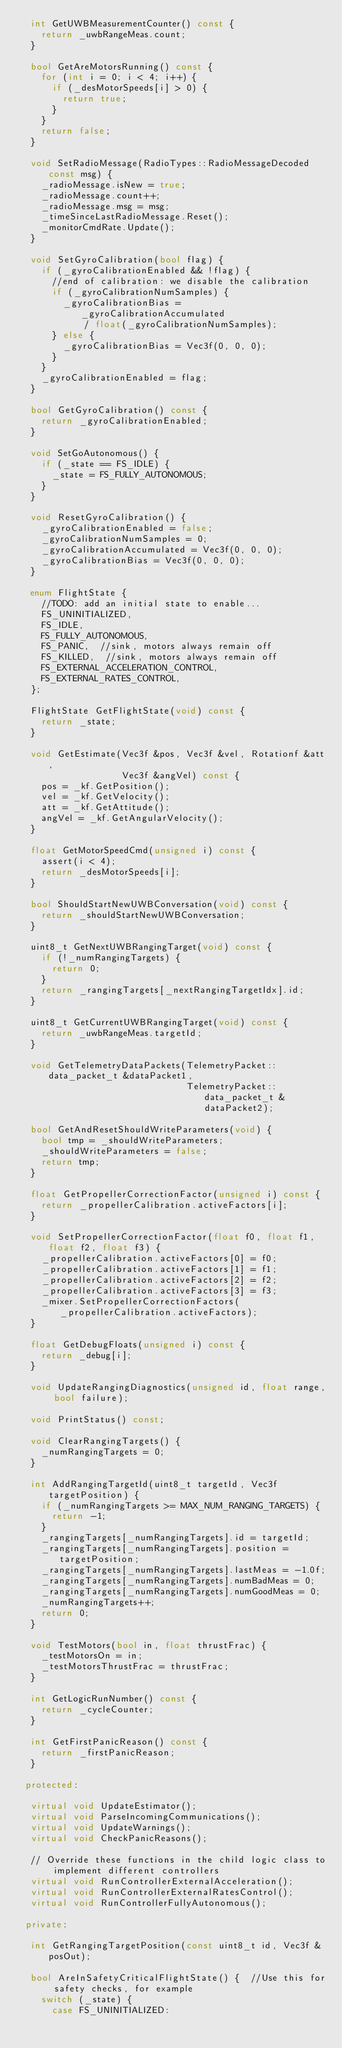<code> <loc_0><loc_0><loc_500><loc_500><_C++_>  int GetUWBMeasurementCounter() const {
    return _uwbRangeMeas.count;
  }

  bool GetAreMotorsRunning() const {
    for (int i = 0; i < 4; i++) {
      if (_desMotorSpeeds[i] > 0) {
        return true;
      }
    }
    return false;
  }

  void SetRadioMessage(RadioTypes::RadioMessageDecoded const msg) {
    _radioMessage.isNew = true;
    _radioMessage.count++;
    _radioMessage.msg = msg;
    _timeSinceLastRadioMessage.Reset();
    _monitorCmdRate.Update();
  }

  void SetGyroCalibration(bool flag) {
    if (_gyroCalibrationEnabled && !flag) {
      //end of calibration: we disable the calibration
      if (_gyroCalibrationNumSamples) {
        _gyroCalibrationBias = _gyroCalibrationAccumulated
            / float(_gyroCalibrationNumSamples);
      } else {
        _gyroCalibrationBias = Vec3f(0, 0, 0);
      }
    }
    _gyroCalibrationEnabled = flag;
  }

  bool GetGyroCalibration() const {
    return _gyroCalibrationEnabled;
  }

  void SetGoAutonomous() {
    if (_state == FS_IDLE) {
      _state = FS_FULLY_AUTONOMOUS;
    }
  }

  void ResetGyroCalibration() {
    _gyroCalibrationEnabled = false;
    _gyroCalibrationNumSamples = 0;
    _gyroCalibrationAccumulated = Vec3f(0, 0, 0);
    _gyroCalibrationBias = Vec3f(0, 0, 0);
  }

  enum FlightState {
    //TODO: add an initial state to enable...
    FS_UNINITIALIZED,
    FS_IDLE,
    FS_FULLY_AUTONOMOUS,
    FS_PANIC,  //sink, motors always remain off
    FS_KILLED,  //sink, motors always remain off
    FS_EXTERNAL_ACCELERATION_CONTROL,
    FS_EXTERNAL_RATES_CONTROL,
  };

  FlightState GetFlightState(void) const {
    return _state;
  }

  void GetEstimate(Vec3f &pos, Vec3f &vel, Rotationf &att,
                   Vec3f &angVel) const {
    pos = _kf.GetPosition();
    vel = _kf.GetVelocity();
    att = _kf.GetAttitude();
    angVel = _kf.GetAngularVelocity();
  }

  float GetMotorSpeedCmd(unsigned i) const {
    assert(i < 4);
    return _desMotorSpeeds[i];
  }

  bool ShouldStartNewUWBConversation(void) const {
    return _shouldStartNewUWBConversation;
  }

  uint8_t GetNextUWBRangingTarget(void) const {
    if (!_numRangingTargets) {
      return 0;
    }
    return _rangingTargets[_nextRangingTargetIdx].id;
  }

  uint8_t GetCurrentUWBRangingTarget(void) const {
    return _uwbRangeMeas.targetId;
  }

  void GetTelemetryDataPackets(TelemetryPacket::data_packet_t &dataPacket1,
                               TelemetryPacket::data_packet_t &dataPacket2);

  bool GetAndResetShouldWriteParameters(void) {
    bool tmp = _shouldWriteParameters;
    _shouldWriteParameters = false;
    return tmp;
  }

  float GetPropellerCorrectionFactor(unsigned i) const {
    return _propellerCalibration.activeFactors[i];
  }

  void SetPropellerCorrectionFactor(float f0, float f1, float f2, float f3) {
    _propellerCalibration.activeFactors[0] = f0;
    _propellerCalibration.activeFactors[1] = f1;
    _propellerCalibration.activeFactors[2] = f2;
    _propellerCalibration.activeFactors[3] = f3;
    _mixer.SetPropellerCorrectionFactors(_propellerCalibration.activeFactors);
  }

  float GetDebugFloats(unsigned i) const {
    return _debug[i];
  }

  void UpdateRangingDiagnostics(unsigned id, float range, bool failure);

  void PrintStatus() const;

  void ClearRangingTargets() {
    _numRangingTargets = 0;
  }

  int AddRangingTargetId(uint8_t targetId, Vec3f targetPosition) {
    if (_numRangingTargets >= MAX_NUM_RANGING_TARGETS) {
      return -1;
    }
    _rangingTargets[_numRangingTargets].id = targetId;
    _rangingTargets[_numRangingTargets].position = targetPosition;
    _rangingTargets[_numRangingTargets].lastMeas = -1.0f;
    _rangingTargets[_numRangingTargets].numBadMeas = 0;
    _rangingTargets[_numRangingTargets].numGoodMeas = 0;
    _numRangingTargets++;
    return 0;
  }

  void TestMotors(bool in, float thrustFrac) {
    _testMotorsOn = in;
    _testMotorsThrustFrac = thrustFrac;
  }

  int GetLogicRunNumber() const {
    return _cycleCounter;
  }

  int GetFirstPanicReason() const {
    return _firstPanicReason;
  }

 protected:

  virtual void UpdateEstimator();
  virtual void ParseIncomingCommunications();
  virtual void UpdateWarnings();
  virtual void CheckPanicReasons();

  // Override these functions in the child logic class to implement different controllers
  virtual void RunControllerExternalAcceleration();
  virtual void RunControllerExternalRatesControl();
  virtual void RunControllerFullyAutonomous();

 private:

  int GetRangingTargetPosition(const uint8_t id, Vec3f &posOut);

  bool AreInSafetyCriticalFlightState() {  //Use this for safety checks, for example
    switch (_state) {
      case FS_UNINITIALIZED:</code> 